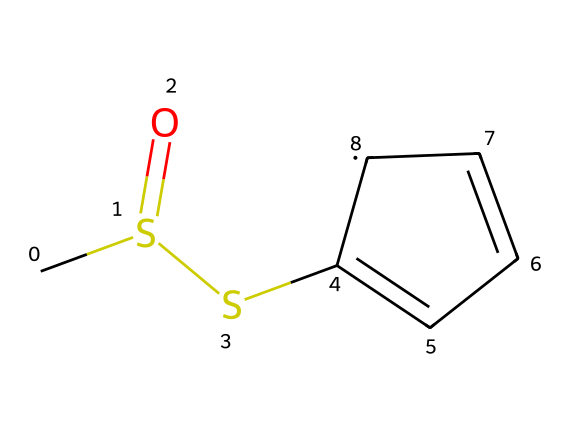What is the molecular formula of allicin? By analyzing the SMILES representation, count the atoms: 3 carbon (C), 6 hydrogen (H), 2 sulfur (S), and 1 oxygen (O), giving us a molecular formula of C3H6S2O.
Answer: C3H6S2O How many sulfur atoms are present in the structure? The SMILES representation indicates two instances of 'S', which means there are two sulfur atoms in the compound.
Answer: 2 What type of functional group is present in allicin? The presence of sulfur and oxygen in the structure indicates the presence of a sulfoxide functional group, as seen by the 'S(=O)' part of the SMILES.
Answer: sulfoxide Is this compound likely to be polar or nonpolar? The presence of the sulfoxide functional group and the electronegative sulfur and oxygen suggest that allicin will be polar due to its uneven charge distribution.
Answer: polar How many rings are present in the molecular structure of allicin? There is a cyclic structure denoted by 'C1=CC=C' which indicates one ring in the compound.
Answer: 1 What kind of chemical reaction might involve allicin due to its sulfur-containing structure? Allicin can undergo nucleophilic substitution reactions due to the polar nature of sulfur and its potential reactivity with nucleophiles.
Answer: nucleophilic substitution Which element in this compound is primarily responsible for its characteristic odor? The sulfur atoms in allicin are known for contributing to strong odors, characteristic of garlic products.
Answer: sulfur 